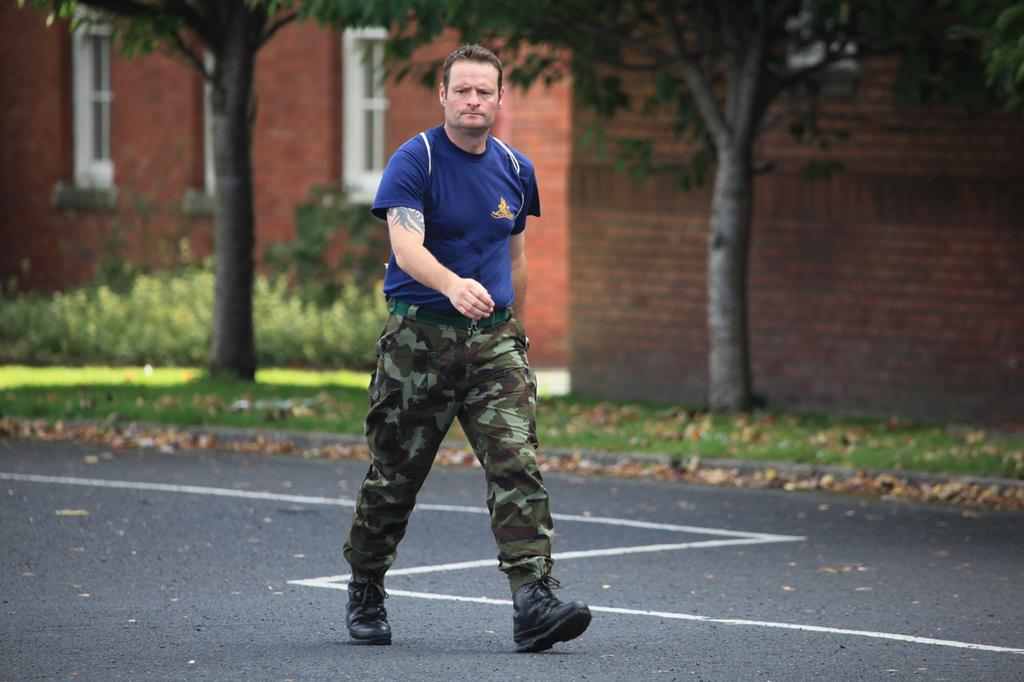What is the man in the image doing? The man is walking on the road. What can be seen in the background of the image? There are trees, plants, and buildings in the background of the image. What type of wall can be seen in the image? There is no wall present in the image. How many cents are visible in the image? There are no cents present in the image. 